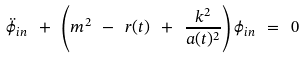Convert formula to latex. <formula><loc_0><loc_0><loc_500><loc_500>\ddot { \phi } _ { i n } \ + \ \left ( m ^ { 2 } \ - \ r ( t ) \ + \ \frac { k ^ { 2 } } { a ( t ) ^ { 2 } } \right ) \phi _ { i n } \ = \ 0</formula> 